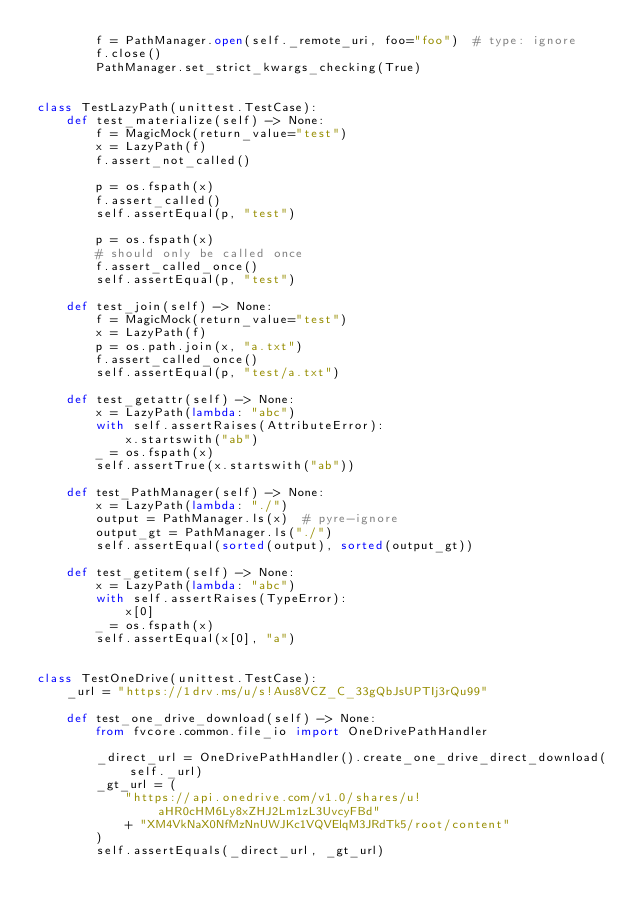<code> <loc_0><loc_0><loc_500><loc_500><_Python_>        f = PathManager.open(self._remote_uri, foo="foo")  # type: ignore
        f.close()
        PathManager.set_strict_kwargs_checking(True)


class TestLazyPath(unittest.TestCase):
    def test_materialize(self) -> None:
        f = MagicMock(return_value="test")
        x = LazyPath(f)
        f.assert_not_called()

        p = os.fspath(x)
        f.assert_called()
        self.assertEqual(p, "test")

        p = os.fspath(x)
        # should only be called once
        f.assert_called_once()
        self.assertEqual(p, "test")

    def test_join(self) -> None:
        f = MagicMock(return_value="test")
        x = LazyPath(f)
        p = os.path.join(x, "a.txt")
        f.assert_called_once()
        self.assertEqual(p, "test/a.txt")

    def test_getattr(self) -> None:
        x = LazyPath(lambda: "abc")
        with self.assertRaises(AttributeError):
            x.startswith("ab")
        _ = os.fspath(x)
        self.assertTrue(x.startswith("ab"))

    def test_PathManager(self) -> None:
        x = LazyPath(lambda: "./")
        output = PathManager.ls(x)  # pyre-ignore
        output_gt = PathManager.ls("./")
        self.assertEqual(sorted(output), sorted(output_gt))

    def test_getitem(self) -> None:
        x = LazyPath(lambda: "abc")
        with self.assertRaises(TypeError):
            x[0]
        _ = os.fspath(x)
        self.assertEqual(x[0], "a")


class TestOneDrive(unittest.TestCase):
    _url = "https://1drv.ms/u/s!Aus8VCZ_C_33gQbJsUPTIj3rQu99"

    def test_one_drive_download(self) -> None:
        from fvcore.common.file_io import OneDrivePathHandler

        _direct_url = OneDrivePathHandler().create_one_drive_direct_download(self._url)
        _gt_url = (
            "https://api.onedrive.com/v1.0/shares/u!aHR0cHM6Ly8xZHJ2Lm1zL3UvcyFBd"
            + "XM4VkNaX0NfMzNnUWJKc1VQVElqM3JRdTk5/root/content"
        )
        self.assertEquals(_direct_url, _gt_url)
</code> 